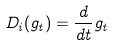<formula> <loc_0><loc_0><loc_500><loc_500>D _ { i } ( g _ { t } ) = \frac { d } { d t } g _ { t }</formula> 